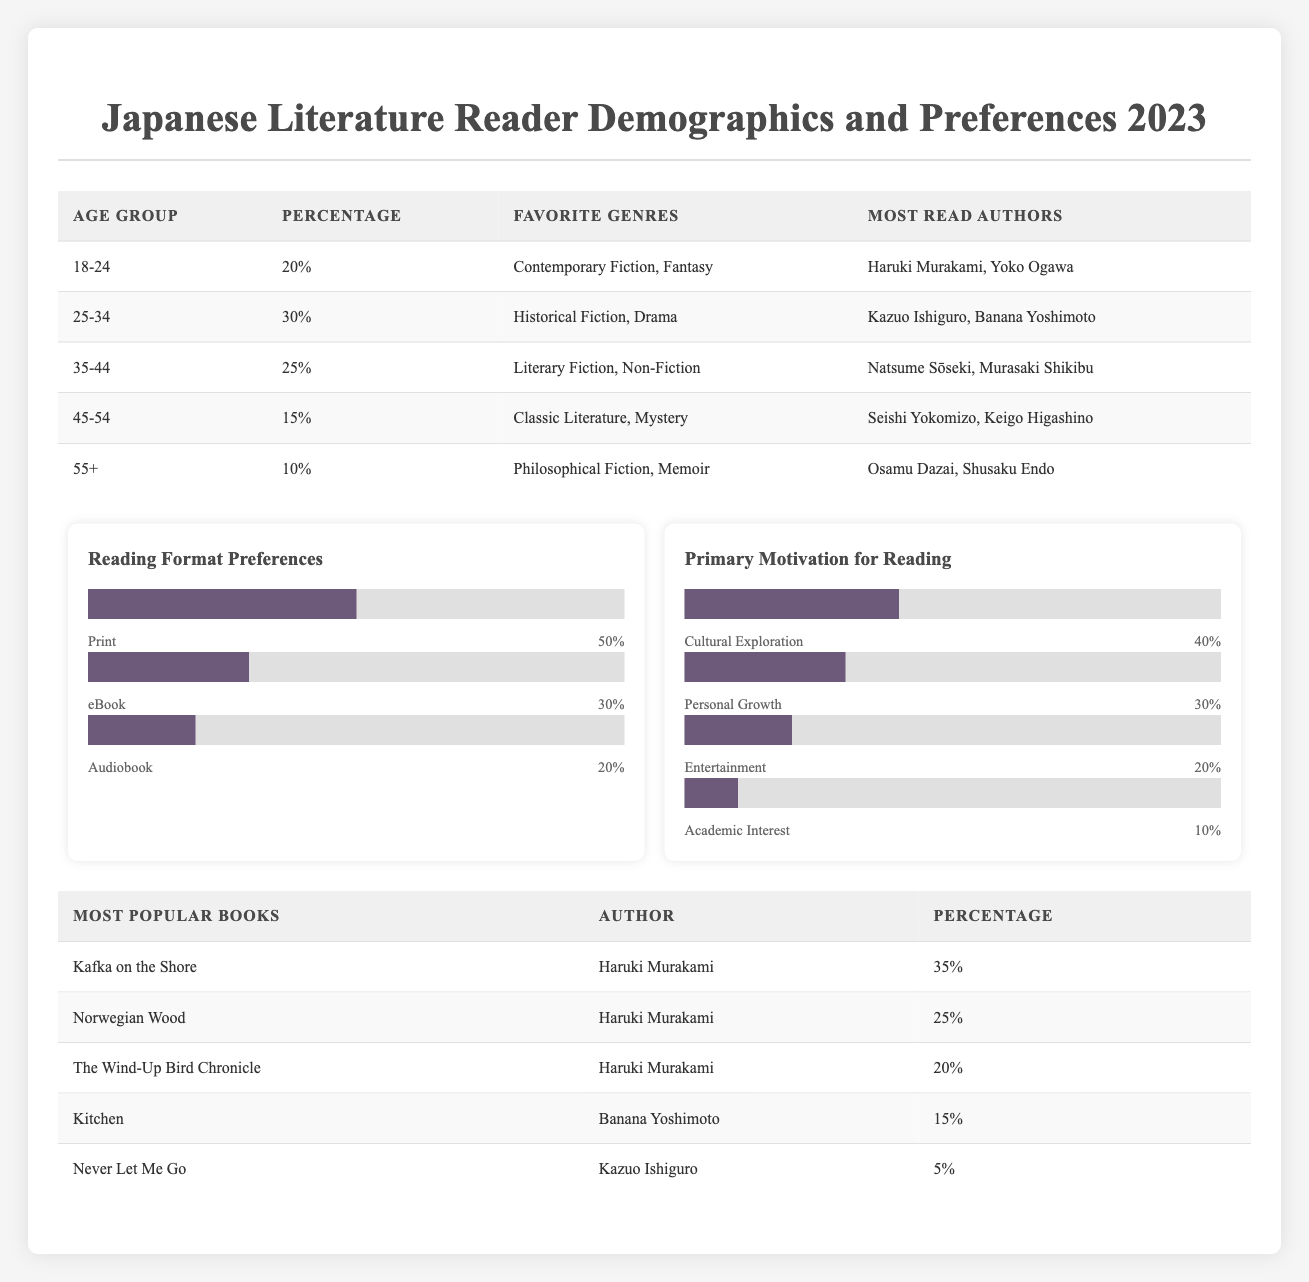What percentage of readers are aged 25-34? The table indicates that the age group 25-34 has a percentage of 30%.
Answer: 30% Which favorite genre is most popular among readers aged 18-24? According to the data, readers aged 18-24 prefer "Contemporary Fiction" and "Fantasy" as their favorite genres, which are equally popular.
Answer: Contemporary Fiction, Fantasy What is the combined percentage of readers aged 45-54 and 55+? From the table, the percentage of readers aged 45-54 is 15%, and for 55+ it is 10%. Adding these percentages gives 15 + 10 = 25%.
Answer: 25% Are "Kazuo Ishiguro" and "Banana Yoshimoto" popular among the same age group? "Kazuo Ishiguro" is most read by readers aged 25-34, while "Banana Yoshimoto" is also most read by the same age group. Therefore, they are popular among the same group.
Answer: Yes What is the most commonly preferred reading format among all readers? The table shows the distribution of reading formats: Print (50%), eBook (30%), and Audiobook (20%). Print has the highest percentage, making it the most preferred reading format.
Answer: Print Which age group has the least representation among readers? The age group with the least percentage is 55+, with only 10% of readers falling into this category.
Answer: 55+ What is the percentage of readers motivated by entertainment? Looking at the motivation data, 20% of readers indicated their primary motivation for reading is entertainment.
Answer: 20% What is the total percentage of readers who prefer "Cultural Exploration" and "Personal Growth" as motivations for reading? The percentage for Cultural Exploration is 40% and for Personal Growth is 30%. Summing these gives 40 + 30 = 70%.
Answer: 70% Which author has the highest percentage of readership among the most popular books? The data indicates that Haruki Murakami has the highest readership percentage at 35% for "Kafka on the Shore".
Answer: Haruki Murakami 